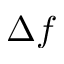Convert formula to latex. <formula><loc_0><loc_0><loc_500><loc_500>\Delta f</formula> 